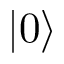Convert formula to latex. <formula><loc_0><loc_0><loc_500><loc_500>| 0 \rangle</formula> 